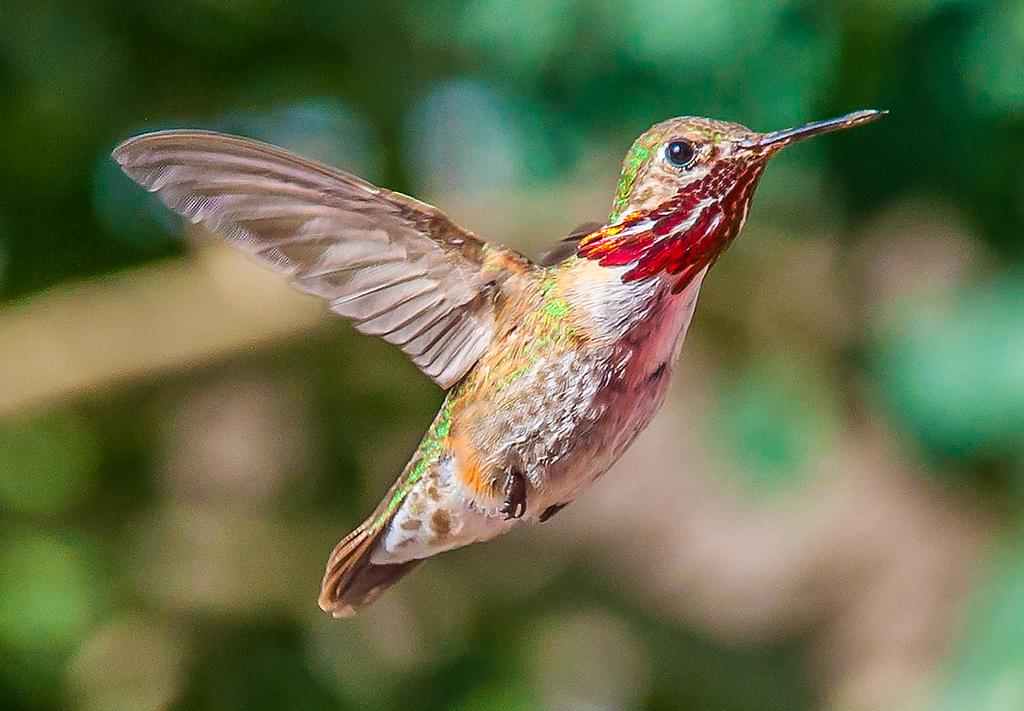What type of animal can be seen in the image? There is a bird in the image. Where is the bird located in the image? The bird is in the air. Can you describe the background of the image? The background of the image is blurred. What type of sand can be seen covering the bird in the image? There is no sand present in the image, and the bird is not covered by any substance. 